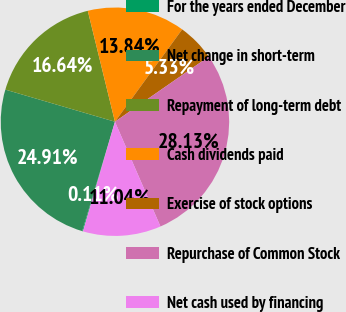<chart> <loc_0><loc_0><loc_500><loc_500><pie_chart><fcel>For the years ended December<fcel>Net change in short-term<fcel>Repayment of long-term debt<fcel>Cash dividends paid<fcel>Exercise of stock options<fcel>Repurchase of Common Stock<fcel>Net cash used by financing<nl><fcel>0.11%<fcel>24.91%<fcel>16.64%<fcel>13.84%<fcel>5.33%<fcel>28.13%<fcel>11.04%<nl></chart> 